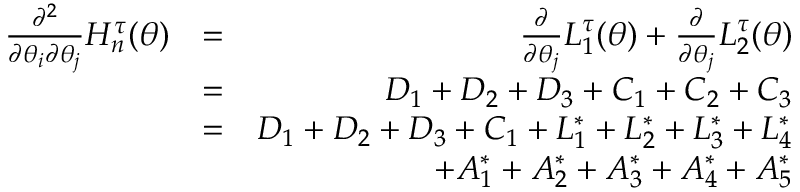<formula> <loc_0><loc_0><loc_500><loc_500>\begin{array} { r l r } { \frac { \partial ^ { 2 } } { \partial \theta _ { i } \partial \theta _ { j } } H _ { n } ^ { \tau } ( \theta ) } & { = } & { \frac { \partial } { \partial \theta _ { j } } L _ { 1 } ^ { \tau } ( \theta ) + \frac { \partial } { \partial \theta _ { j } } L _ { 2 } ^ { \tau } ( \theta ) } \\ & { = } & { D _ { 1 } + D _ { 2 } + D _ { 3 } + C _ { 1 } + C _ { 2 } + C _ { 3 } } \\ & { = } & { D _ { 1 } + D _ { 2 } + D _ { 3 } + C _ { 1 } + L _ { 1 } ^ { \ast } + L _ { 2 } ^ { \ast } + L _ { 3 } ^ { \ast } + L _ { 4 } ^ { \ast } } \\ & { + A _ { 1 } ^ { \ast } + A _ { 2 } ^ { \ast } + A _ { 3 } ^ { \ast } + A _ { 4 } ^ { \ast } + A _ { 5 } ^ { \ast } } \end{array}</formula> 